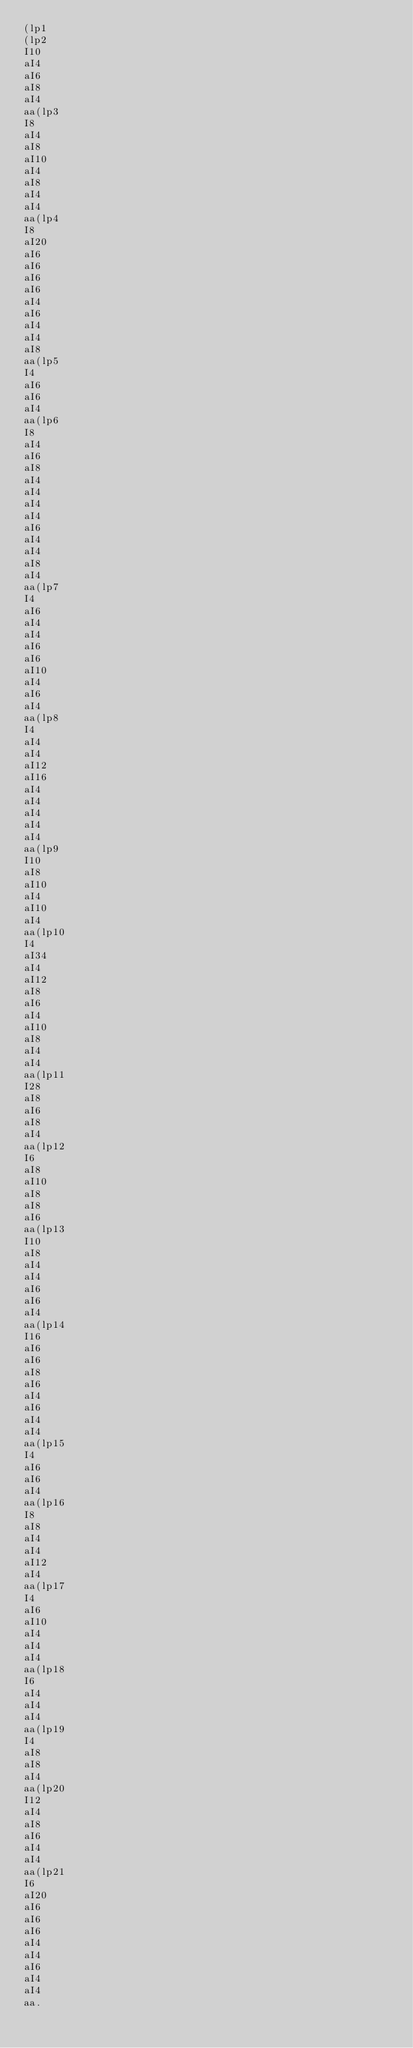Convert code to text. <code><loc_0><loc_0><loc_500><loc_500><_SQL_>(lp1
(lp2
I10
aI4
aI6
aI8
aI4
aa(lp3
I8
aI4
aI8
aI10
aI4
aI8
aI4
aI4
aa(lp4
I8
aI20
aI6
aI6
aI6
aI6
aI4
aI6
aI4
aI4
aI8
aa(lp5
I4
aI6
aI6
aI4
aa(lp6
I8
aI4
aI6
aI8
aI4
aI4
aI4
aI4
aI6
aI4
aI4
aI8
aI4
aa(lp7
I4
aI6
aI4
aI4
aI6
aI6
aI10
aI4
aI6
aI4
aa(lp8
I4
aI4
aI4
aI12
aI16
aI4
aI4
aI4
aI4
aI4
aa(lp9
I10
aI8
aI10
aI4
aI10
aI4
aa(lp10
I4
aI34
aI4
aI12
aI8
aI6
aI4
aI10
aI8
aI4
aI4
aa(lp11
I28
aI8
aI6
aI8
aI4
aa(lp12
I6
aI8
aI10
aI8
aI8
aI6
aa(lp13
I10
aI8
aI4
aI4
aI6
aI6
aI4
aa(lp14
I16
aI6
aI6
aI8
aI6
aI4
aI6
aI4
aI4
aa(lp15
I4
aI6
aI6
aI4
aa(lp16
I8
aI8
aI4
aI4
aI12
aI4
aa(lp17
I4
aI6
aI10
aI4
aI4
aI4
aa(lp18
I6
aI4
aI4
aI4
aa(lp19
I4
aI8
aI8
aI4
aa(lp20
I12
aI4
aI8
aI6
aI4
aI4
aa(lp21
I6
aI20
aI6
aI6
aI6
aI4
aI4
aI6
aI4
aI4
aa.</code> 